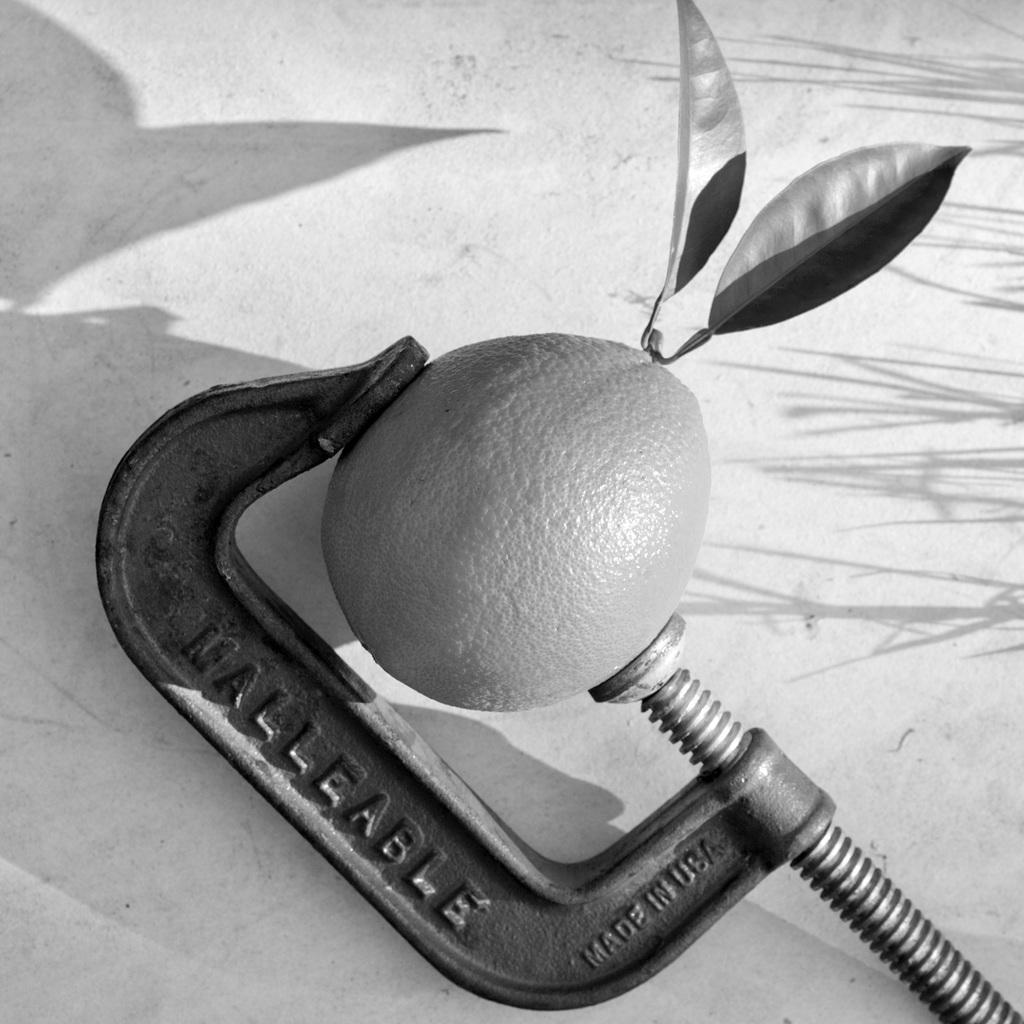Where was this made?
Provide a succinct answer. Usa. What does it say on the long end?
Offer a very short reply. Malleable. 